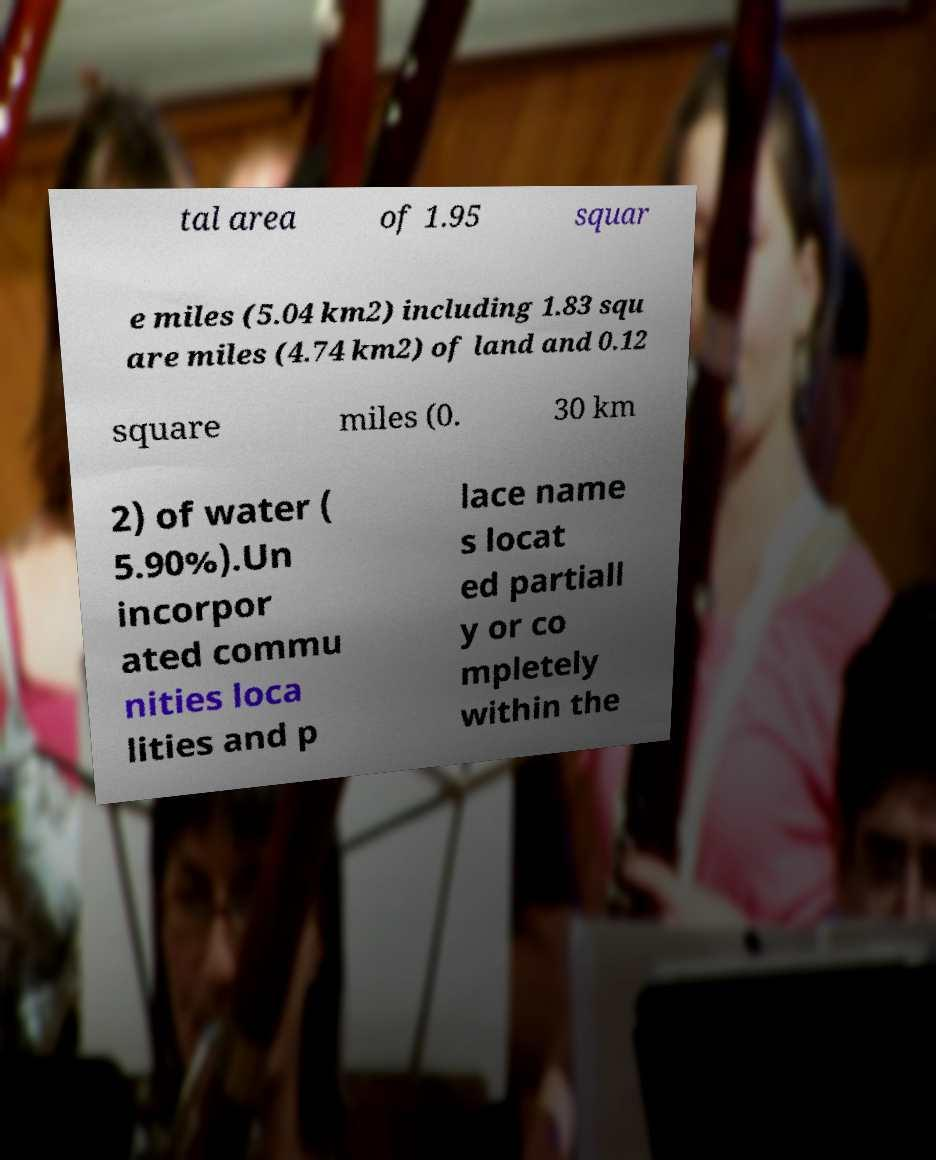I need the written content from this picture converted into text. Can you do that? tal area of 1.95 squar e miles (5.04 km2) including 1.83 squ are miles (4.74 km2) of land and 0.12 square miles (0. 30 km 2) of water ( 5.90%).Un incorpor ated commu nities loca lities and p lace name s locat ed partiall y or co mpletely within the 